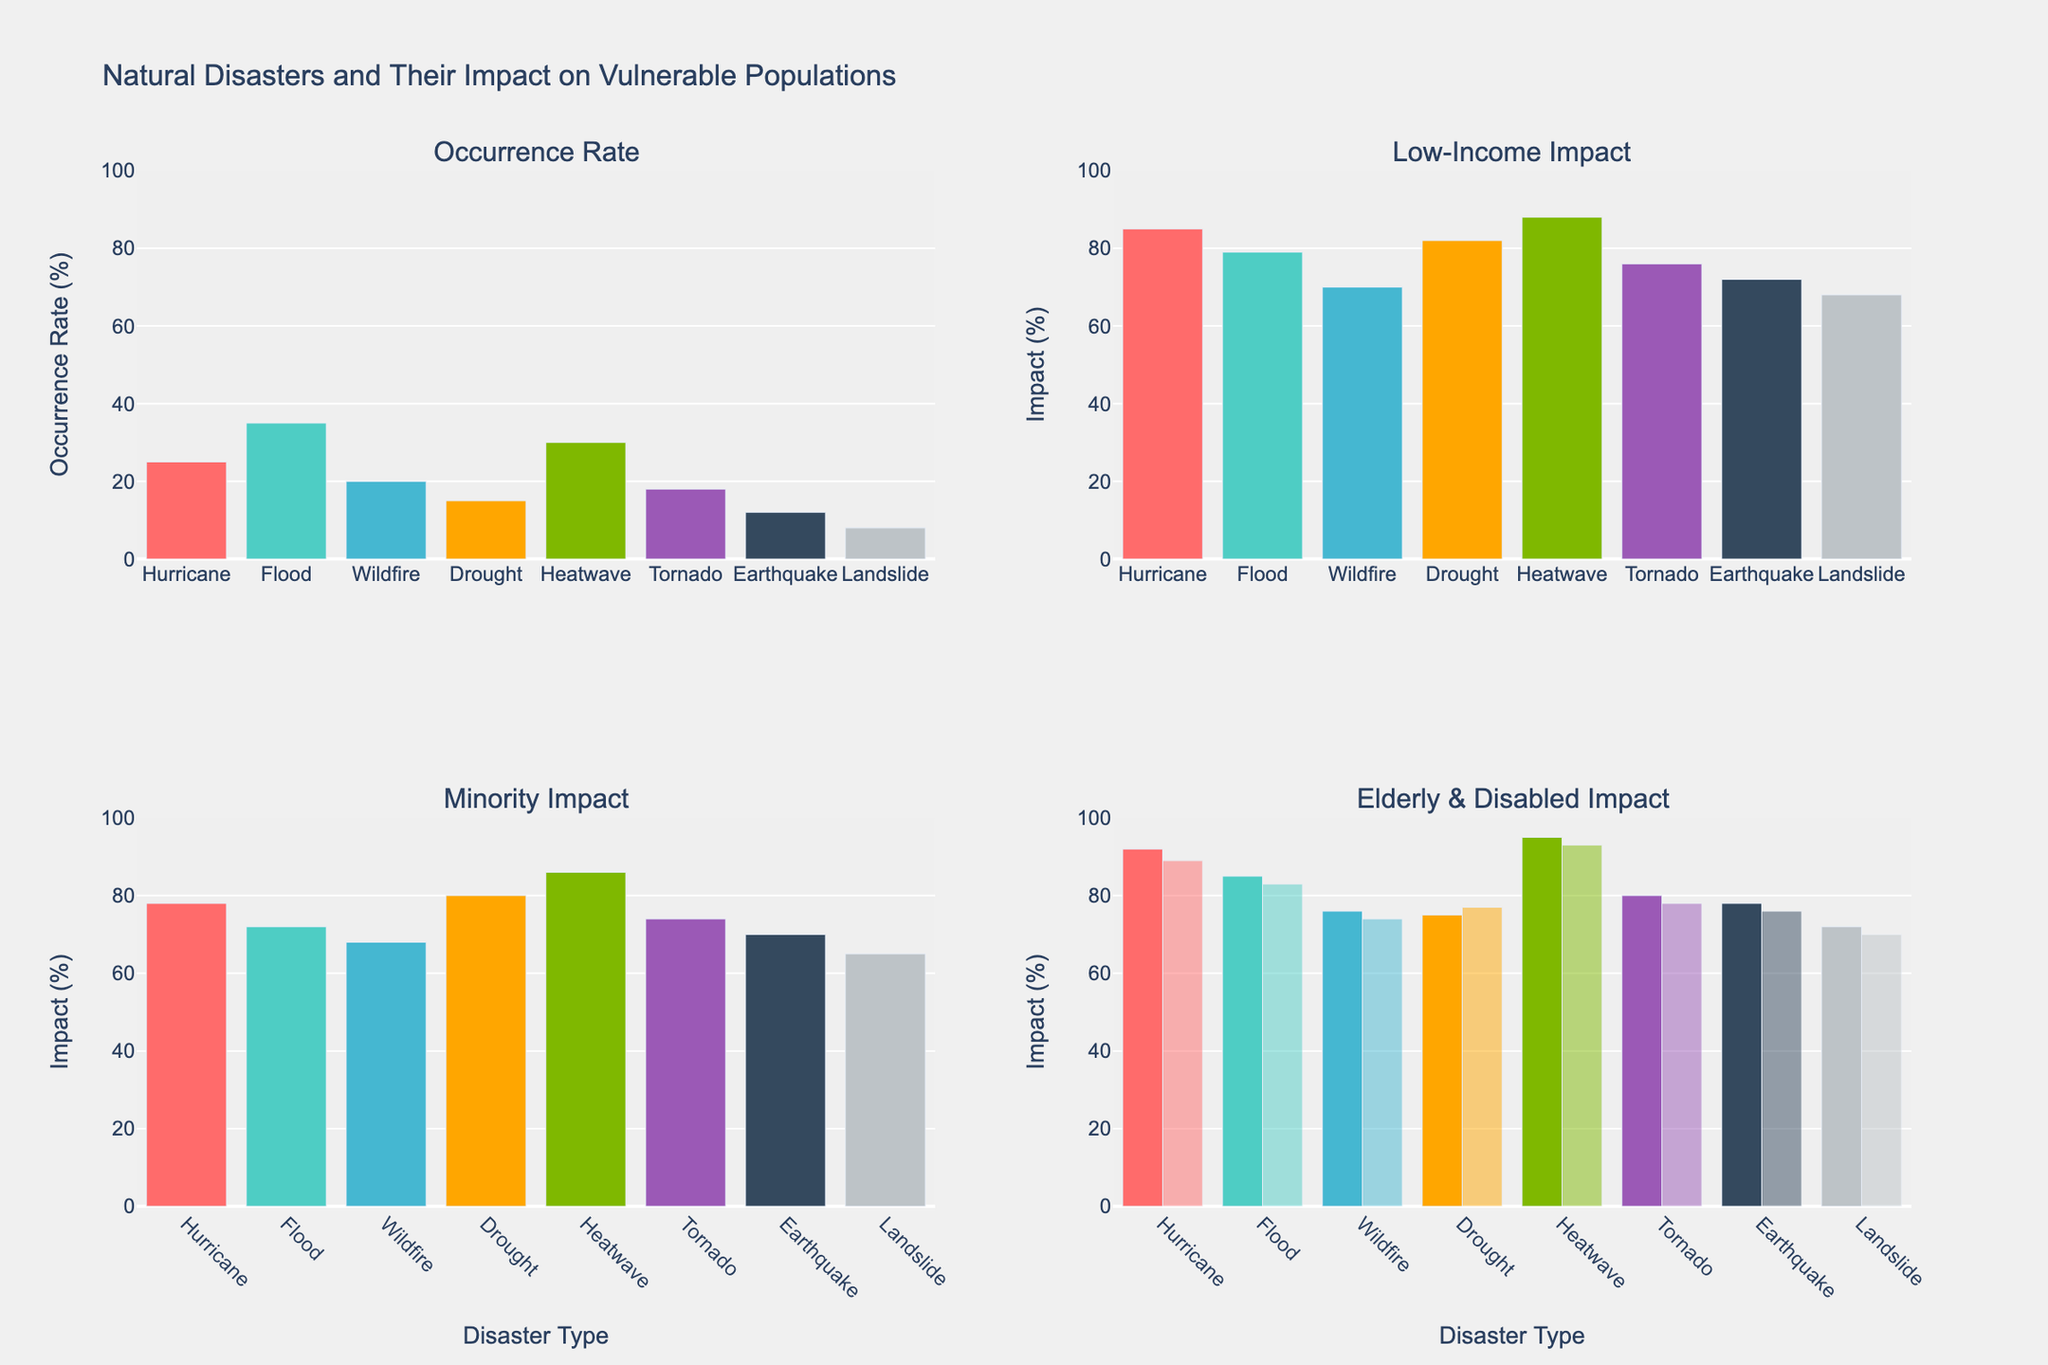What is the title of the figure? The title can be found at the top of the figure, summarizing the data being represented.
Answer: Natural Disasters and Their Impact on Vulnerable Populations What is the occurrence rate of floods? The occurrence rate for each disaster is represented by the height of the bars in the first subplot, labeled "Occurrence Rate". For floods, this is the second bar.
Answer: 35% Which disaster type has the highest impact on the elderly? In the subplot named "Elderly Impact", the tallest bar can be identified, which corresponds to the disaster with the highest impact.
Answer: Heatwave How does the low-income impact of droughts compare to the impact on minorities? Compare the heights of the bars representing droughts in the "Low-Income Impact" subplot and "Minority Impact" subplot.
Answer: Higher on low-income (82%) than minorities (80%) What is the combined impact on the disabled and elderly from hurricanes? The impact on the disabled and elderly for hurricanes is shown in the "Elderly & Disabled Impact" subplot. Add the percentage values for hurricanes for both groups.
Answer: 92% + 89% = 181% Which disaster type impacts minorities the least? Find the shortest bar in the "Minority Impact" subplot which represents the disaster type with the least impact on minorities.
Answer: Landslide What is the average impact of heatwaves on vulnerable populations? Calculate the average of impacts for heatwaves on low-income, minority, elderly, and disabled populations.
Answer: (88 + 86 + 95 + 93) / 4 = 90.5% Compare the occurrence rate of tornadoes with wildfires. Look at the heights of the bars in the "Occurrence Rate" subplot for tornadoes and wildfires.
Answer: Wildfires (20%) occur slightly more than tornadoes (18%) Which disasters have a greater impact on low-income individuals than on the elderly? Analyze both "Low-Income Impact" and "Elderly Impact" subplots and compare the values for each disaster type.
Answer: Drought and Earthquake In the "Elderly & Disabled Impact" subplot, how do hurricanes compare to other disasters in terms of disabled impact? Locate the bar for "Disabled Impact" for hurricanes and compare its height to other bars in the same subplot.
Answer: Hurricanes have a higher disabled impact (89%) than most other disasters 